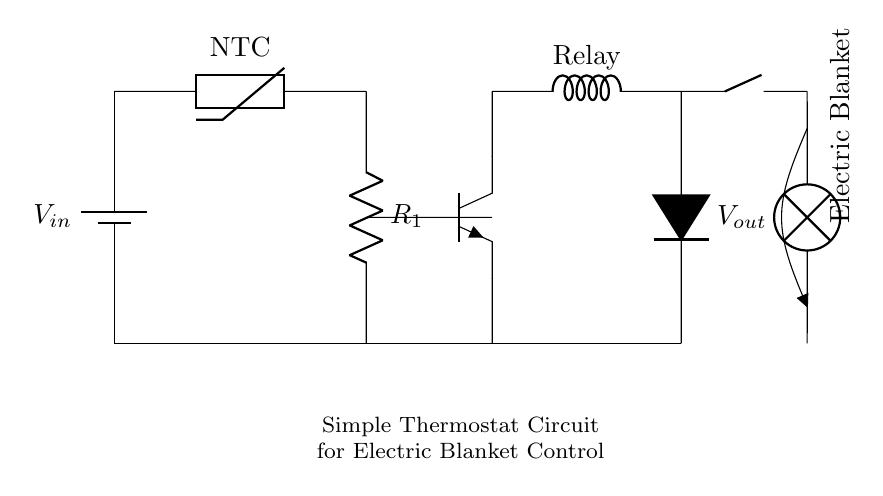What type of component is the thermistor? The thermistor, shown in the circuit, is labeled as an NTC (Negative Temperature Coefficient) thermistor. This indicates that its resistance decreases as temperature increases.
Answer: NTC thermistor What does the relay do in this circuit? The relay acts as a switch that controls the power to the electric blanket based on the input from the thermistor and the transistor. It opens or closes the circuit for the blanket.
Answer: Switch What is the role of the transistor in the circuit? The transistor amplifies the control signal from the thermistor, allowing it to activate the relay which controls the electric blanket. Without the transistor, the relay may not be energized.
Answer: Amplifier What is the supply voltage for this circuit? The supply voltage, noted as Vin, is the voltage provided to the circuit from the battery, depicted at the top left of the diagram. The exact voltage is not specified in the circuit but is an essential part of its function.
Answer: Vin How is the electric blanket powered? The electric blanket is powered by the voltage output (Vout) through the relay when it is activated. The diagram indicates that the blanket connects to the relay switch, allowing it to receive power.
Answer: Vout What happens if the temperature measured by the thermistor increases? When the temperature increases, the resistance of the NTC thermistor decreases, which leads to a potential increase in the current flow through the base of the transistor, potentially activating the relay and powering the electric blanket.
Answer: It activates the blanket 